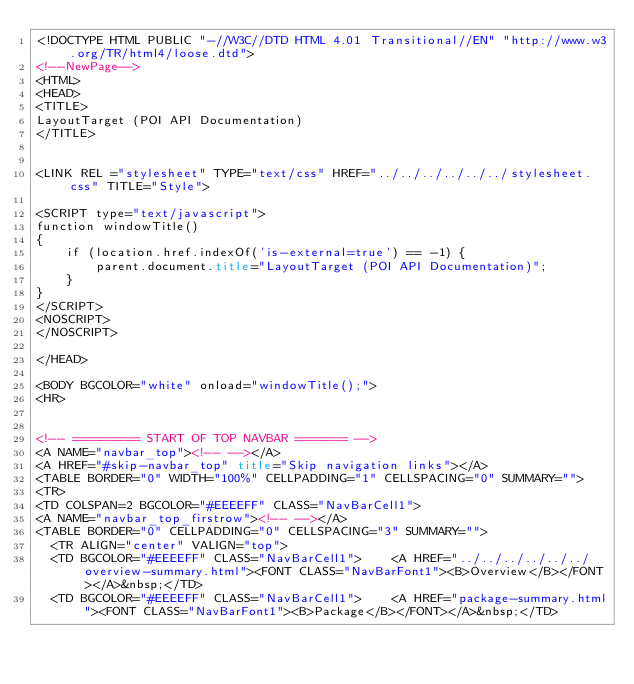<code> <loc_0><loc_0><loc_500><loc_500><_HTML_><!DOCTYPE HTML PUBLIC "-//W3C//DTD HTML 4.01 Transitional//EN" "http://www.w3.org/TR/html4/loose.dtd">
<!--NewPage-->
<HTML>
<HEAD>
<TITLE>
LayoutTarget (POI API Documentation)
</TITLE>


<LINK REL ="stylesheet" TYPE="text/css" HREF="../../../../../../stylesheet.css" TITLE="Style">

<SCRIPT type="text/javascript">
function windowTitle()
{
    if (location.href.indexOf('is-external=true') == -1) {
        parent.document.title="LayoutTarget (POI API Documentation)";
    }
}
</SCRIPT>
<NOSCRIPT>
</NOSCRIPT>

</HEAD>

<BODY BGCOLOR="white" onload="windowTitle();">
<HR>


<!-- ========= START OF TOP NAVBAR ======= -->
<A NAME="navbar_top"><!-- --></A>
<A HREF="#skip-navbar_top" title="Skip navigation links"></A>
<TABLE BORDER="0" WIDTH="100%" CELLPADDING="1" CELLSPACING="0" SUMMARY="">
<TR>
<TD COLSPAN=2 BGCOLOR="#EEEEFF" CLASS="NavBarCell1">
<A NAME="navbar_top_firstrow"><!-- --></A>
<TABLE BORDER="0" CELLPADDING="0" CELLSPACING="3" SUMMARY="">
  <TR ALIGN="center" VALIGN="top">
  <TD BGCOLOR="#EEEEFF" CLASS="NavBarCell1">    <A HREF="../../../../../../overview-summary.html"><FONT CLASS="NavBarFont1"><B>Overview</B></FONT></A>&nbsp;</TD>
  <TD BGCOLOR="#EEEEFF" CLASS="NavBarCell1">    <A HREF="package-summary.html"><FONT CLASS="NavBarFont1"><B>Package</B></FONT></A>&nbsp;</TD></code> 